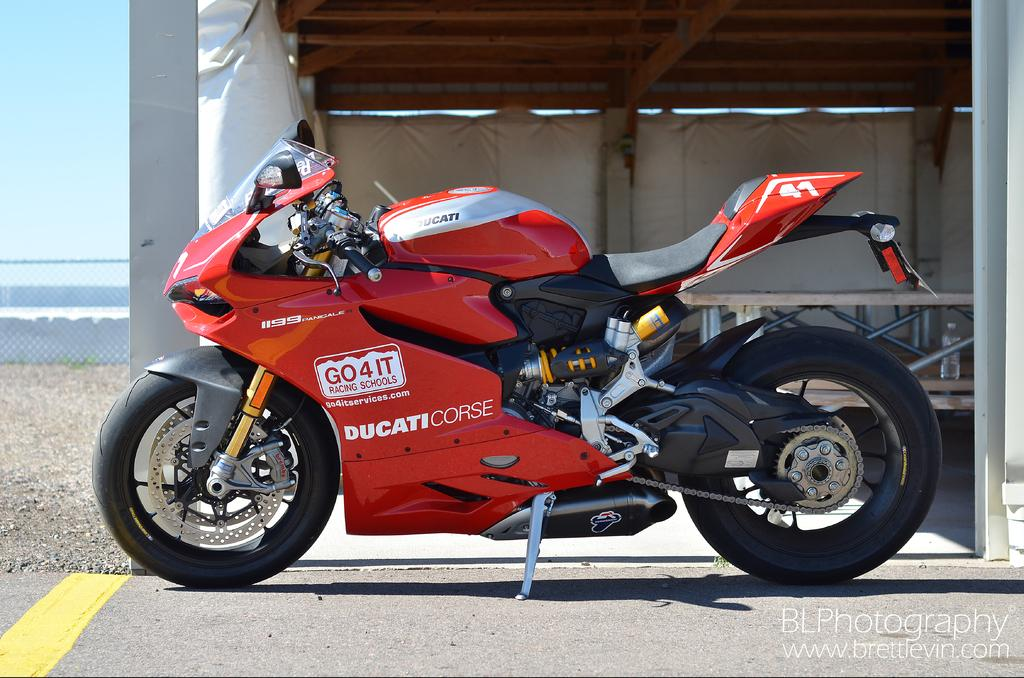<image>
Provide a brief description of the given image. A red speed bike written DUCATICORSE  is on the tarmac 